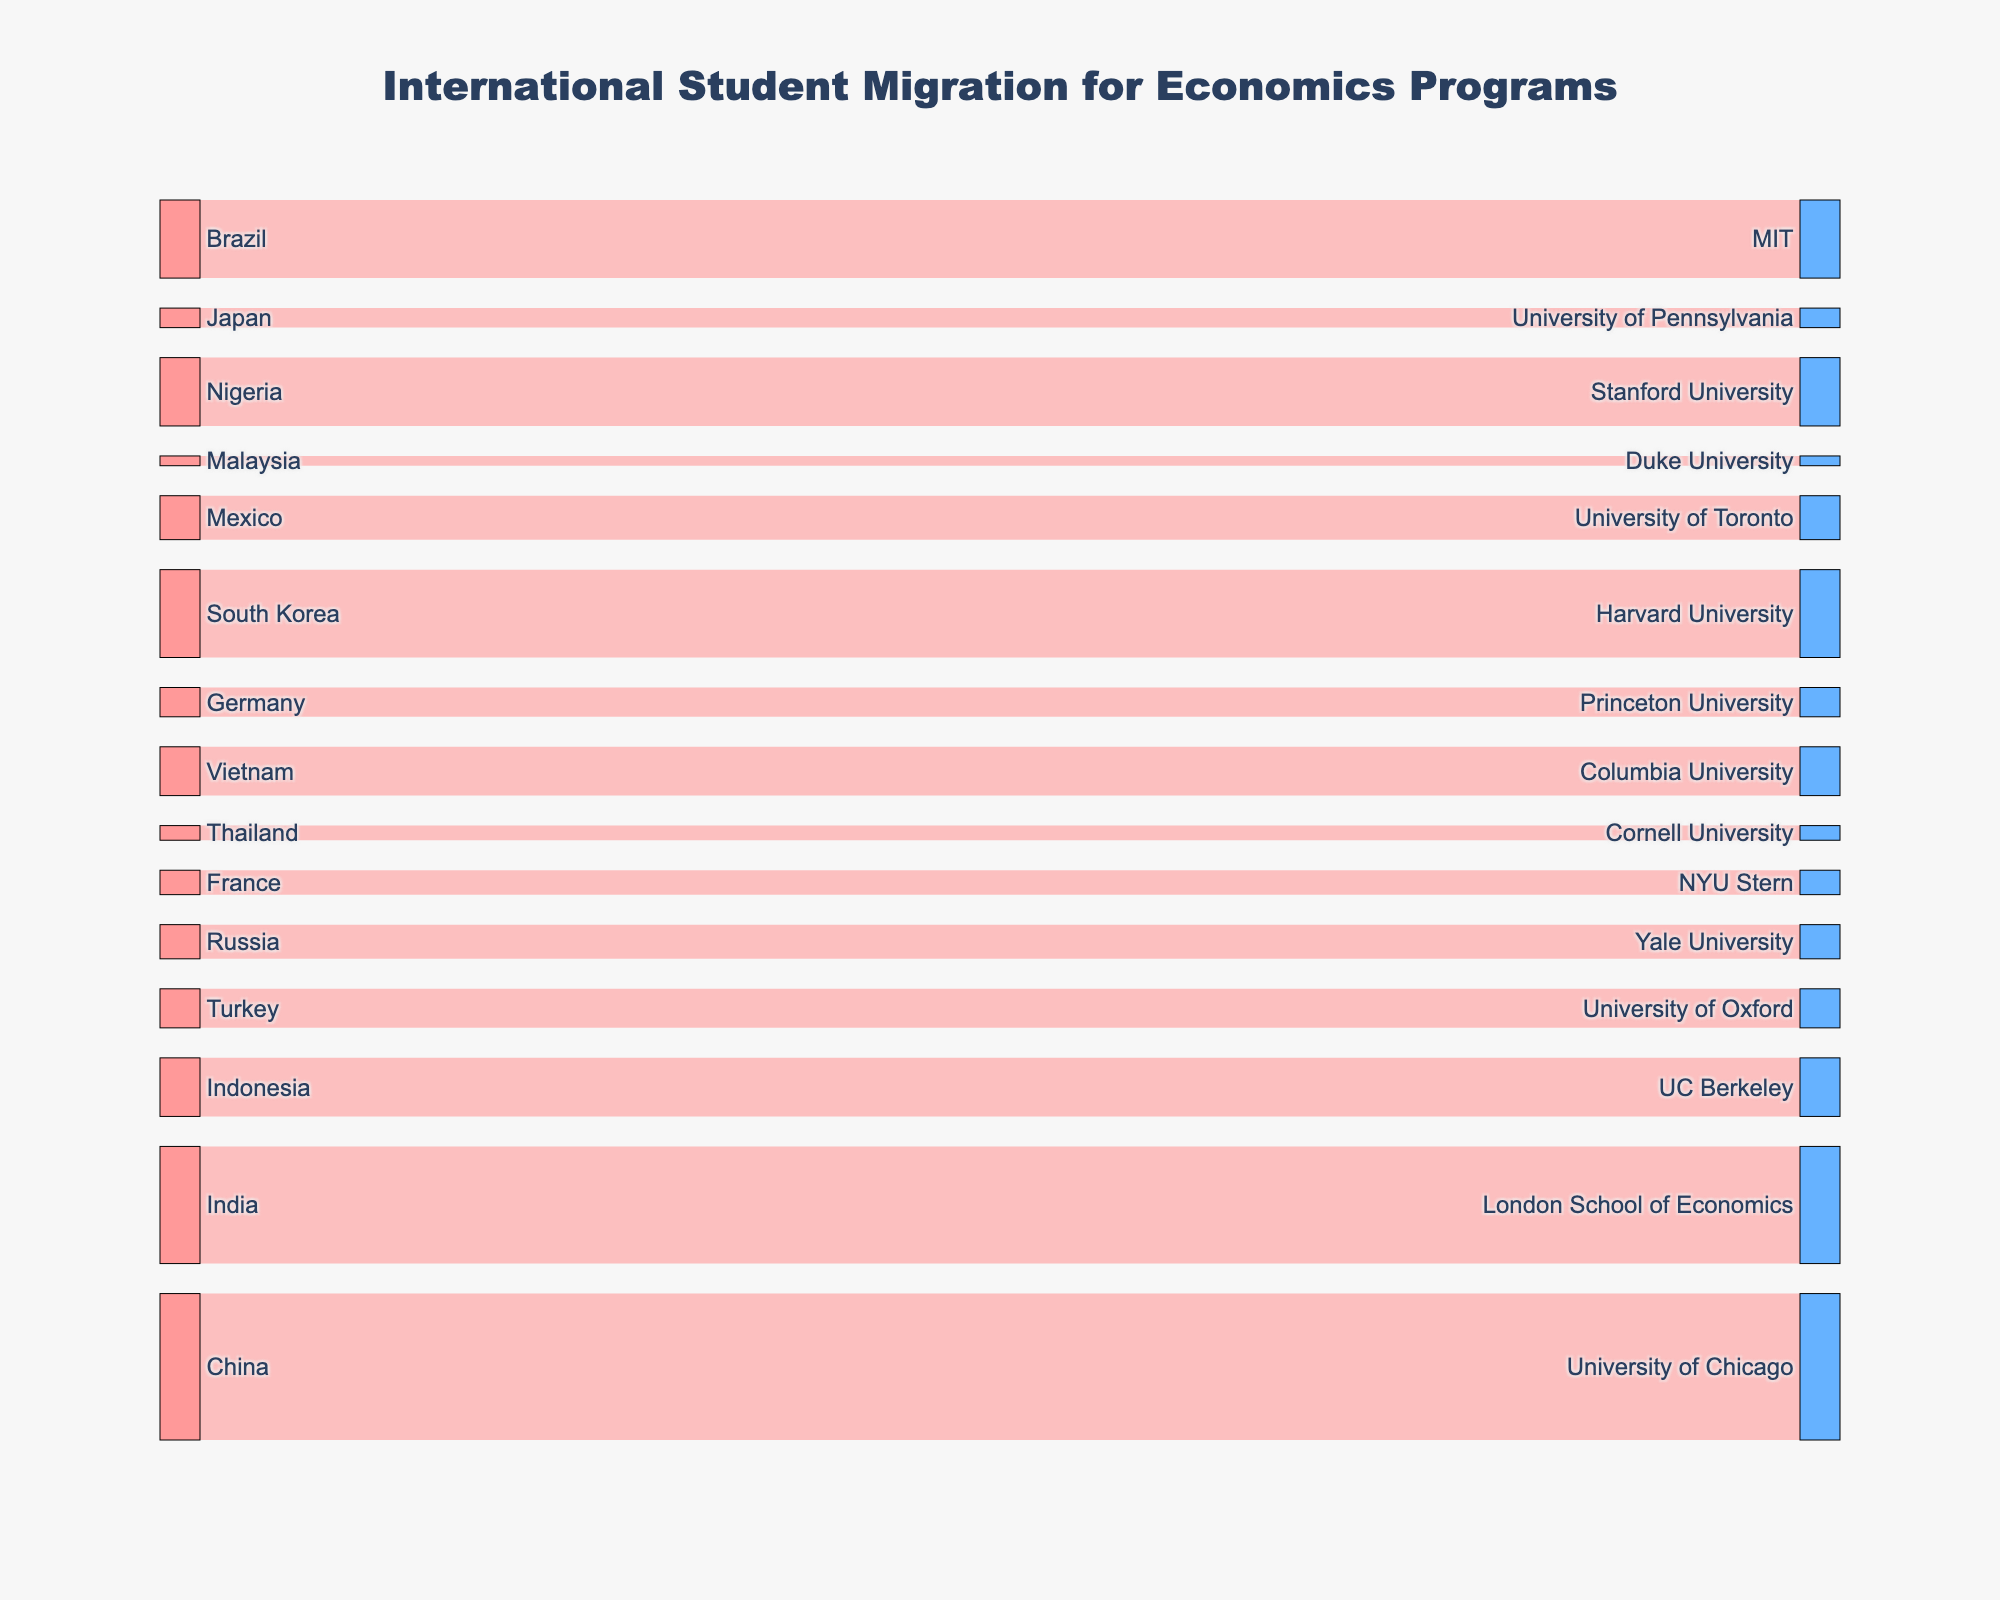What is the main topic of the Sankey diagram? The title of the Sankey Diagram indicates it is about international student migration for economics programs.
Answer: International student migration for economics programs Which source country has the highest number of students migrating to an economics program? The Sankey Diagram shows China has 150 students migrating to the University of Chicago, which is the highest figure among all source countries.
Answer: China How many students from Africa are migrating to economics programs, and which university are they going to? The only African country listed is Nigeria, with 70 students migrating to Stanford University.
Answer: 70, Stanford University What is the total number of students migrating from Asian countries to economics programs? To find the total, sum the number of students from China, India, South Korea, Indonesia, Vietnam, Japan, Thailand, and Malaysia: 150 (China) + 120 (India) + 90 (South Korea) + 60 (Indonesia) + 50 (Vietnam) + 20 (Japan) + 15 (Thailand) + 10 (Malaysia) = 515.
Answer: 515 Which European country has the highest number of students migrating, and which university are they attending? Among European countries listed: Germany, France, and Turkey, Turkey has the highest number (40), and the students are attending the University of Oxford.
Answer: Turkey, University of Oxford Compare the number of students migrating from China to the University of Chicago versus from India to the London School of Economics. China has 150 students migrating to the University of Chicago, while India has 120 students going to the London School of Economics. China has more students migrating to the listed university.
Answer: China What is the total number of students migrating to universities in the United States? To calculate the total, sum the students going to University of Chicago, Harvard University, MIT, Stanford University, UC Berkeley, Columbia University, Yale University, Princeton University, and University of Pennsylvania: 150 + 90 + 80 + 70 + 60 + 50 + 35 + 30 + 20 = 585.
Answer: 585 Which target university receives the least number of international students for economics programs, and from which country? Duke University receives the least number of students, which is 10 from Malaysia.
Answer: Duke University, Malaysia What is the combined number of students from the top three source countries? The top three source countries by the number of students are China (150), India (120), and South Korea (90). The combined number is 150 + 120 + 90 = 360.
Answer: 360 Which university in the UK has students migrating from Mexico, and how many? The University in the UK that has students from Mexico is the University of Oxford, but students from Mexico are actually migrating to the University of Toronto.
Answer: University of Toronto, 45 